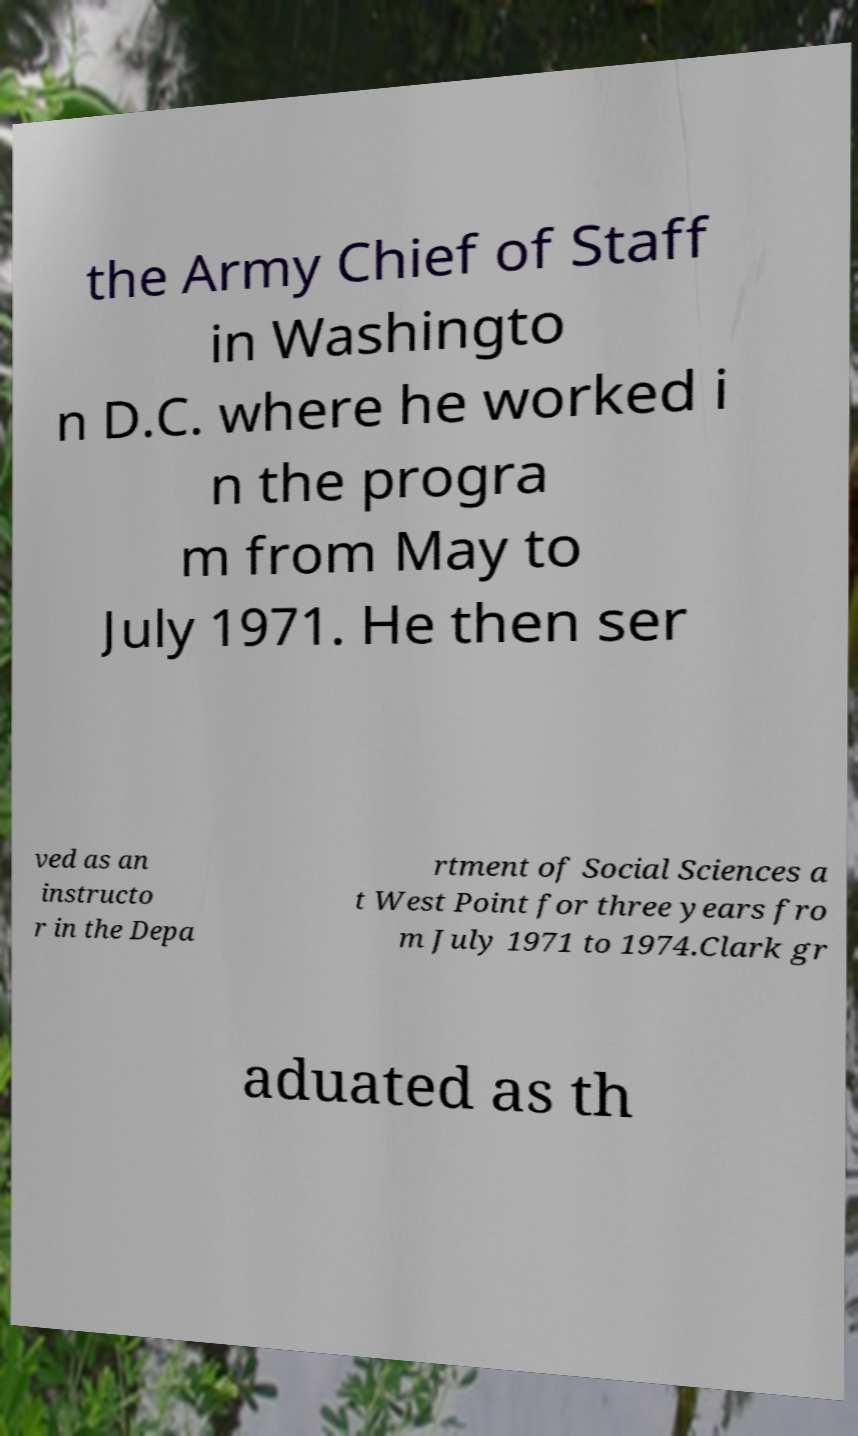Could you assist in decoding the text presented in this image and type it out clearly? the Army Chief of Staff in Washingto n D.C. where he worked i n the progra m from May to July 1971. He then ser ved as an instructo r in the Depa rtment of Social Sciences a t West Point for three years fro m July 1971 to 1974.Clark gr aduated as th 